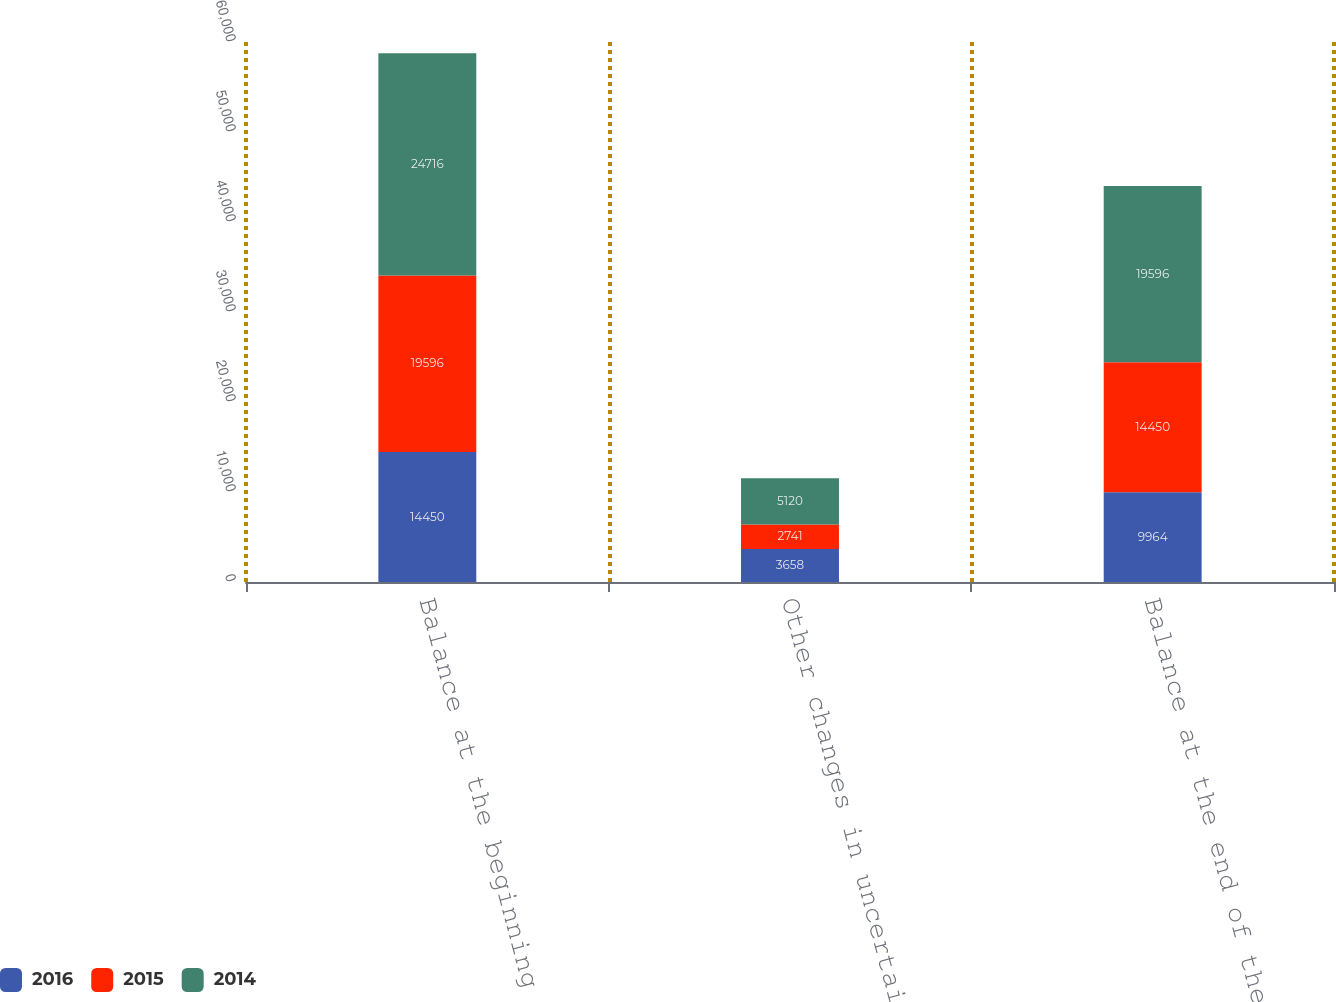Convert chart. <chart><loc_0><loc_0><loc_500><loc_500><stacked_bar_chart><ecel><fcel>Balance at the beginning of<fcel>Other changes in uncertain tax<fcel>Balance at the end of the<nl><fcel>2016<fcel>14450<fcel>3658<fcel>9964<nl><fcel>2015<fcel>19596<fcel>2741<fcel>14450<nl><fcel>2014<fcel>24716<fcel>5120<fcel>19596<nl></chart> 